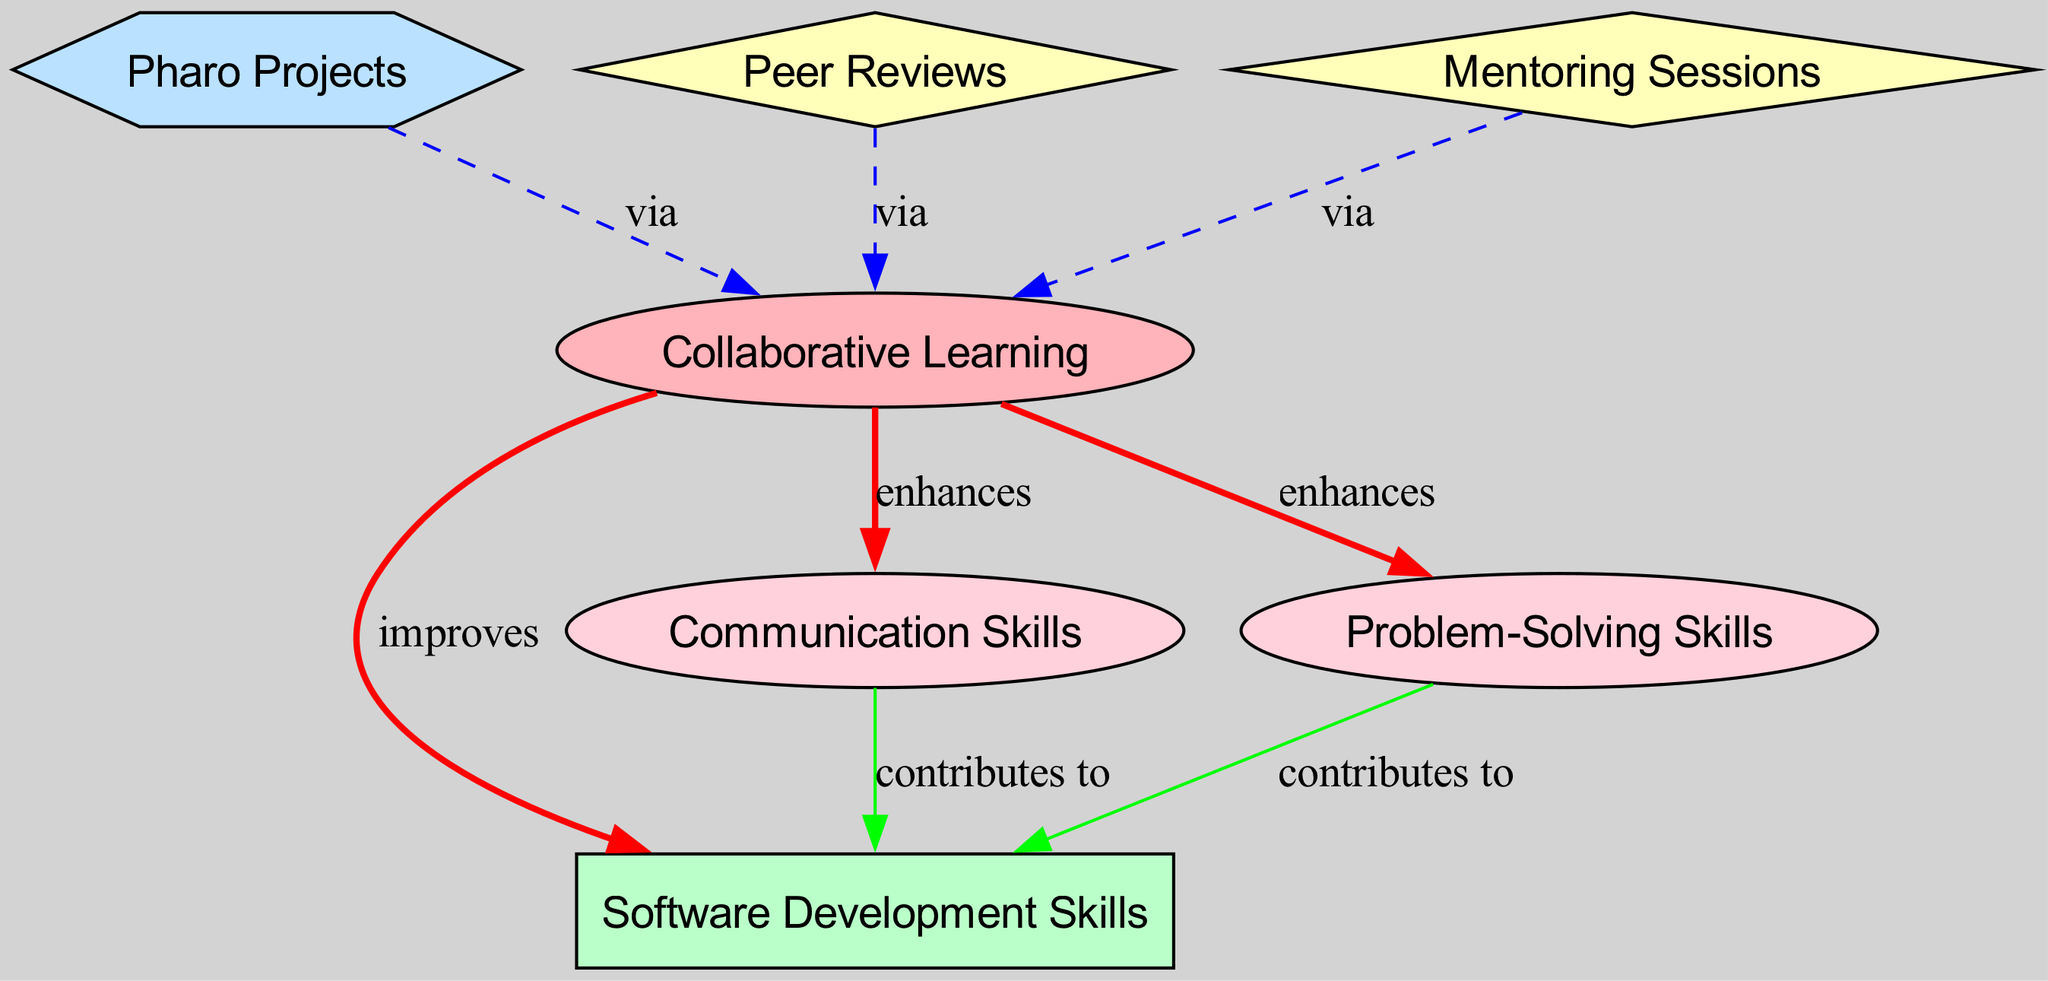What is the main concept of the diagram? The main concept is identified in the "nodes" section of the diagram under the label "Collaborative Learning." This node is foundational as it connects various outcomes and skills related to software development.
Answer: Collaborative Learning How many methods are present in the diagram? By counting the nodes of type "method," which are "Peer Reviews" and "Mentoring Sessions," the total number is determined.
Answer: 2 What skill is enhanced by Collaborative Learning? The diagram explicitly states that "Communication Skills" and "Problem-Solving Skills" are both enhanced by "Collaborative Learning," as shown in the connecting edges.
Answer: Communication Skills Which activity facilitates Collaborative Learning according to the diagram? The diagram shows that "Pharo Projects," "Peer Reviews," and "Mentoring Sessions" all serve as activities that facilitate "Collaborative Learning," which is indicated by the edges. One can observe these connections visually.
Answer: Pharo Projects What type of relationship exists between Problem-Solving Skills and Software Development Skills? Upon examining the edges, it can be seen that "Problem-Solving Skills" contributes to "Software Development Skills," and this relationship is outlined in the diagram as an "enhances" type of edge.
Answer: contributes to Which node has the most connections in the diagram? By carefully counting the edges, "Collaborative Learning" connects to three nodes and also has three incoming edges, implying a central role in the network.
Answer: Collaborative Learning How does Peer Reviews affect Collaborative Learning? The diagram indicates that "Peer Reviews" facilitate "Collaborative Learning," showing a directional connection with the edge labeled "via" from Peer Reviews to Collaborative Learning.
Answer: facilitates What is the color of the node representing Software Development Skills? According to the node styles defined in the diagram, "Software Development Skills" is classified as an "outcome," which means it has a specific color code distinct from other types. The rectangle shape filled with the color "#BAFFC9" identifies it.
Answer: BAFFC9 How many impacts are shown on the Software Development Skills? Counting the edges leading into the "Software Development Skills" node, there are two distinct connections, both labeled as "contributes to," which signify the impacts clearly stated in the diagram.
Answer: 2 